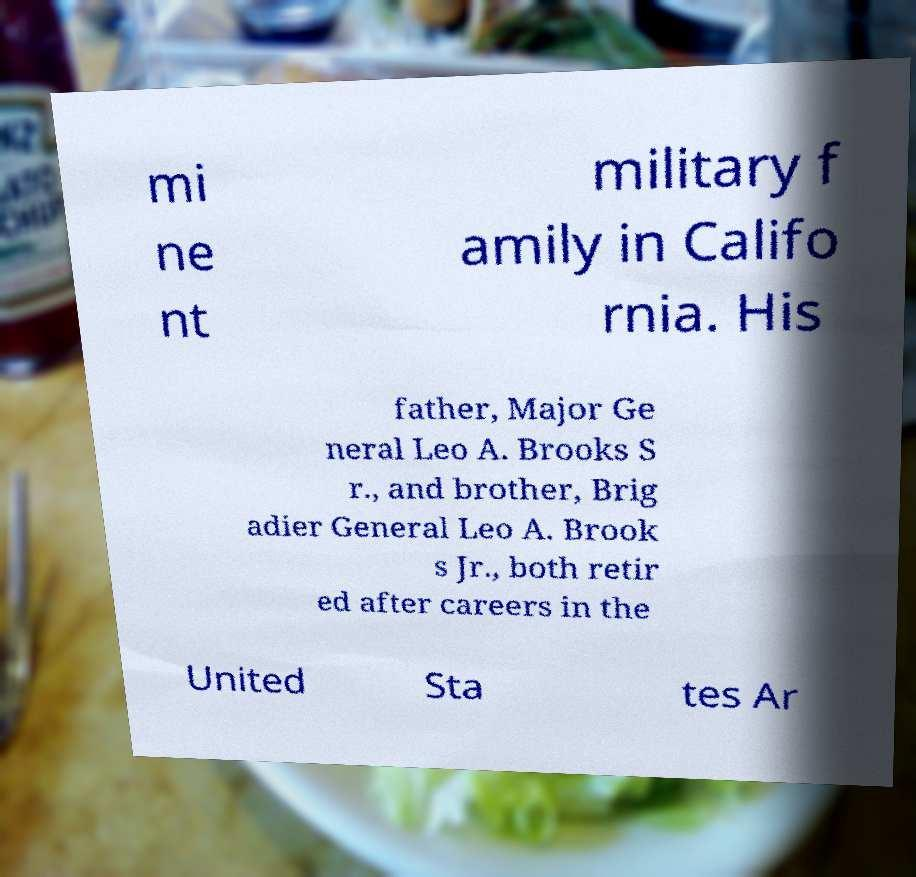Can you read and provide the text displayed in the image?This photo seems to have some interesting text. Can you extract and type it out for me? mi ne nt military f amily in Califo rnia. His father, Major Ge neral Leo A. Brooks S r., and brother, Brig adier General Leo A. Brook s Jr., both retir ed after careers in the United Sta tes Ar 